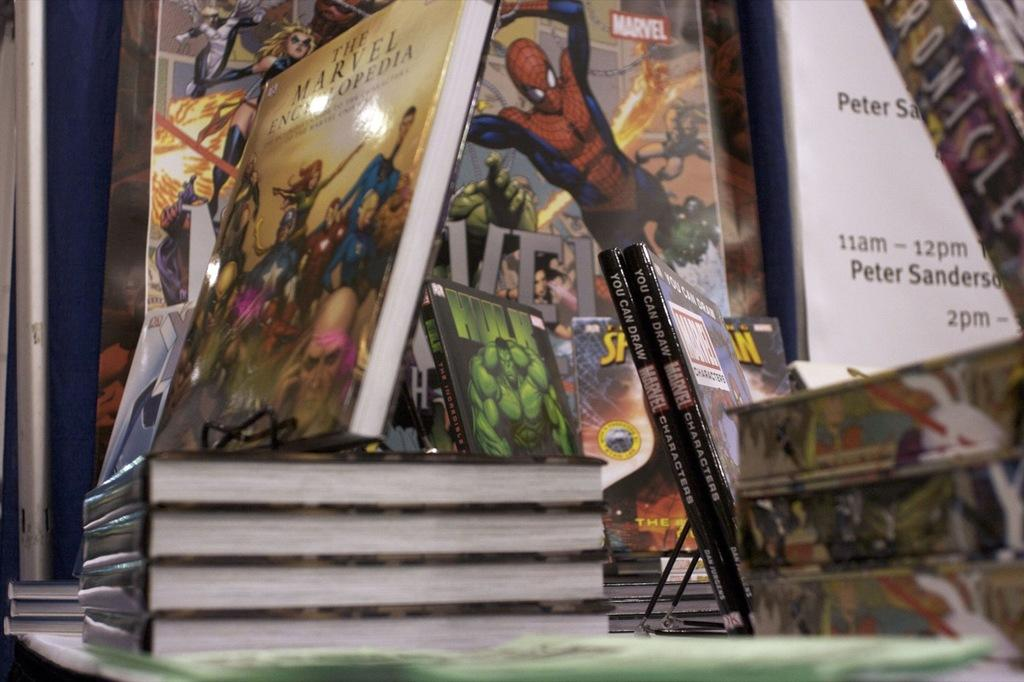<image>
Give a short and clear explanation of the subsequent image. A stack of books titled the Marvel Encyclopedia sit on a table. 